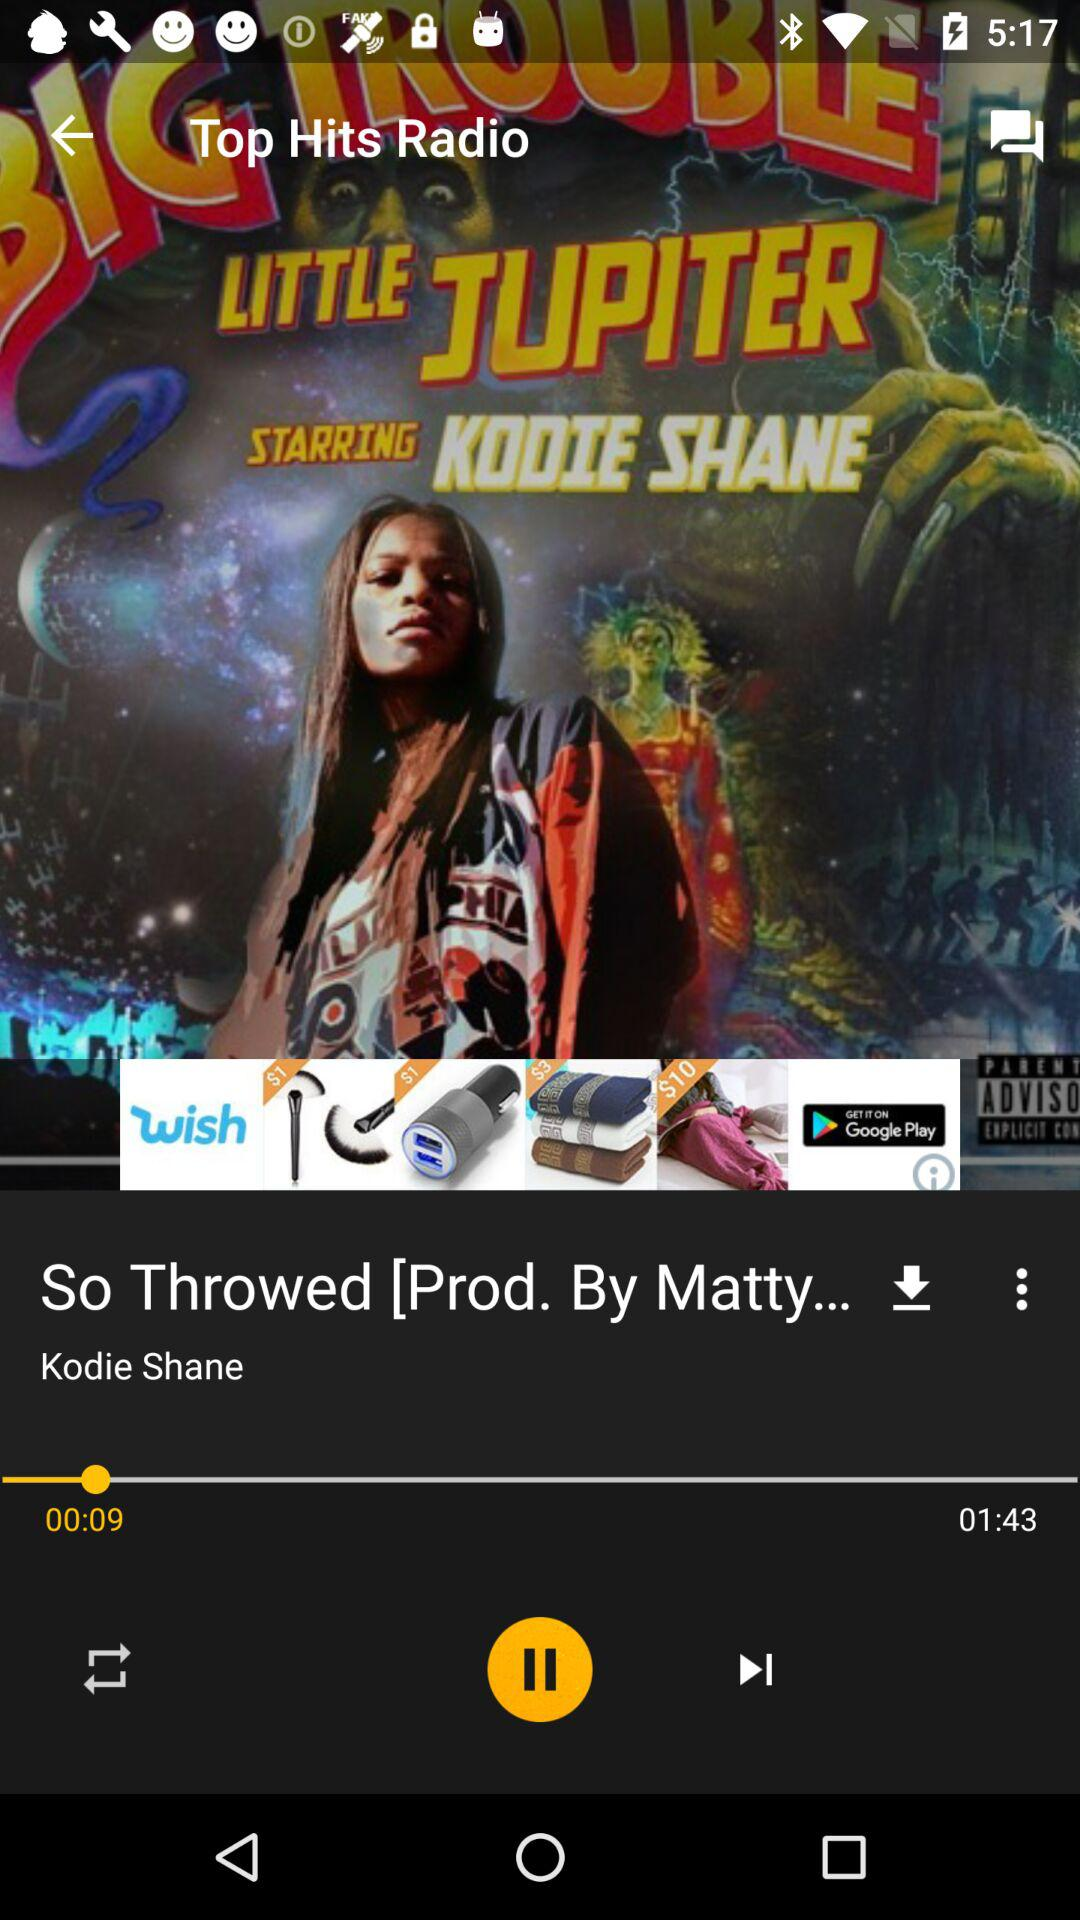What is the name of the audio file? The name of the audio file is "So Throwed". 